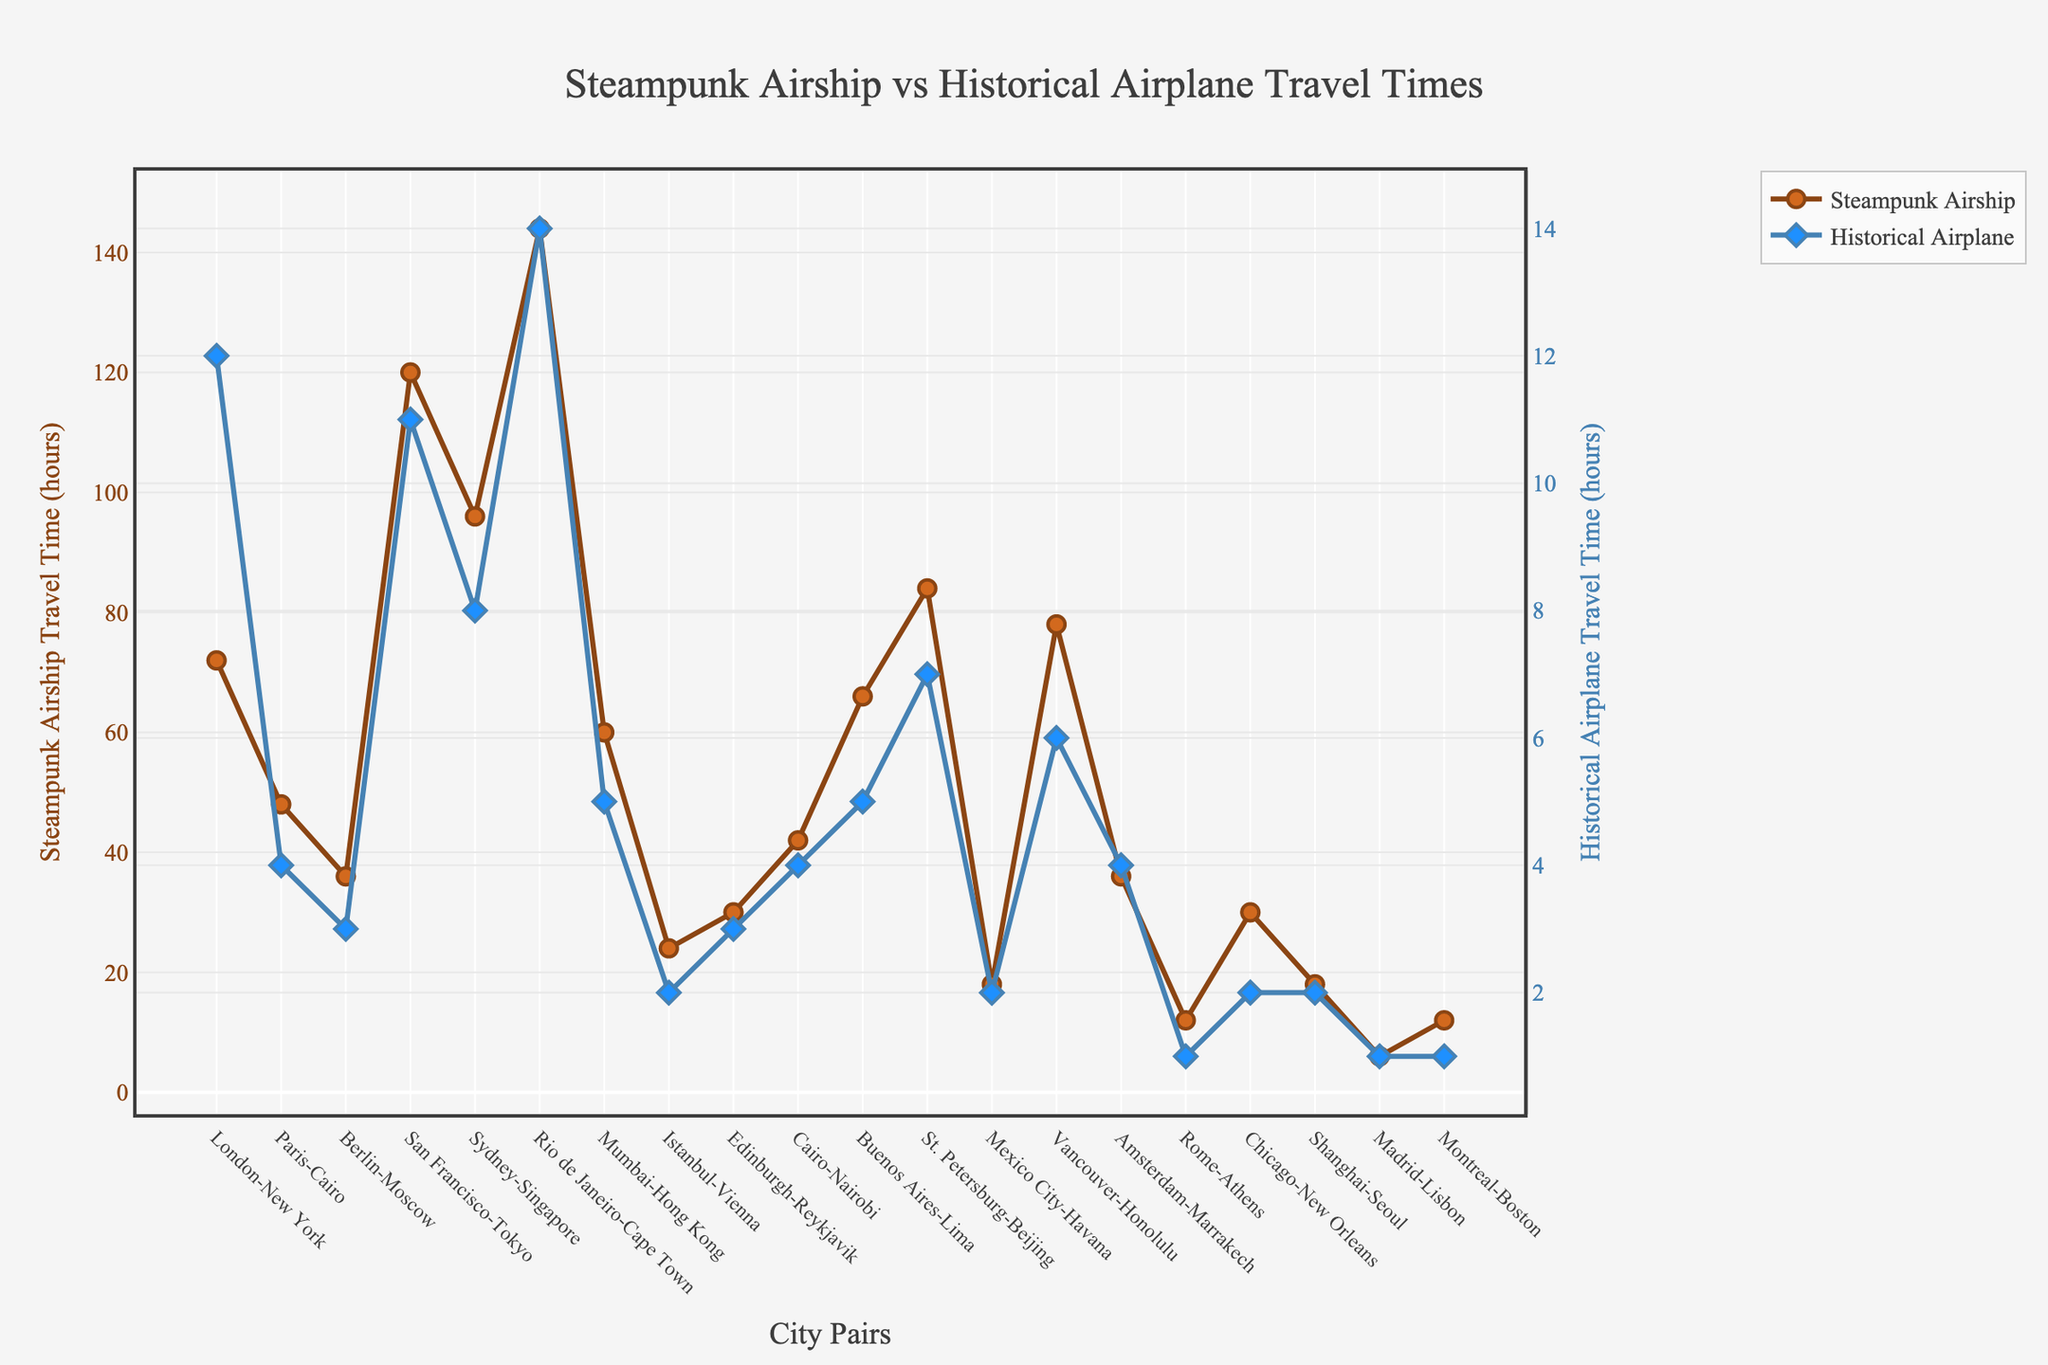What's the difference in travel times between the steampunk airship and the historical airplane for the city pair San Francisco-Tokyo? To find the difference in travel times for the city pair San Francisco-Tokyo, subtract the historical airplane travel time (11 hours) from the steampunk airship travel time (120 hours). The difference is 120 - 11 = 109 hours.
Answer: 109 hours Which city pair has the smallest difference in travel times between the steampunk airship and the historical airplane? By looking at the visual chart, the smallest difference in travel times can be found by comparing the two travel times for each city pair. The city pair with the smallest difference is Madrid-Lisbon with 6 hours for the airship and 1 hour for the airplane, resulting in a 5-hour difference.
Answer: Madrid-Lisbon What is the average historical airplane travel time for all city pairs? To compute the average historical airplane travel time, add up all the historical airplane travel times and divide by the number of city pairs. The travel times are: \(12 + 4 + 3 + 11 + 8 + 14 + 5 + 2 + 3 + 4 + 5 + 7 + 2 + 6 + 4 + 1 + 2 + 2 + 1 + 1 = 97\). There are 20 city pairs, so the average is \(97 \div 20 = 4.85\) hours.
Answer: 4.85 hours Which city pair has the longest steampunk airship travel time? Looking at the figure, the travel time for Rio de Janeiro-Cape Town via the steampunk airship is the longest at 144 hours.
Answer: Rio de Janeiro-Cape Town How much longer does it take to travel from London to New York by steampunk airship compared to historical airplane? To find out how much longer it takes, subtract the historical airplane travel time (12 hours) from the steampunk airship travel time (72 hours). The result is 72 - 12 = 60 hours.
Answer: 60 hours What is the total travel time for steampunk airships for the city pairs Istanbul-Vienna, Chicago-New Orleans, and Shanghai-Seoul? Add the travel times for each of the steampunk airships for these city pairs: Istanbul-Vienna (24 hours), Chicago-New Orleans (30 hours), and Shanghai-Seoul (18 hours). The total is 24 + 30 + 18 = 72 hours.
Answer: 72 hours Which city pair has the greatest travel time disparity between the steampunk airship and the historical airplane? By analyzing the chart, the greatest disparity in travel times can be identified by comparing the differences. The largest disparity is for the city pair San Francisco-Tokyo with the steampunk airship at 120 hours and the historical airplane at 11 hours, resulting in a difference of 109 hours.
Answer: San Francisco-Tokyo What is the median historical airplane travel time for all city pairs? To find the median, first list the airplane travel times in ascending order: 1, 1, 1, 2, 2, 2, 3, 3, 4, 4, 4, 5, 5, 6, 7, 8, 11, 12, 14. With 20 data points, the median is the average of the 10th and 11th values. The 10th and 11th values are both 4, so the average (and median) is 4.
Answer: 4 hours 